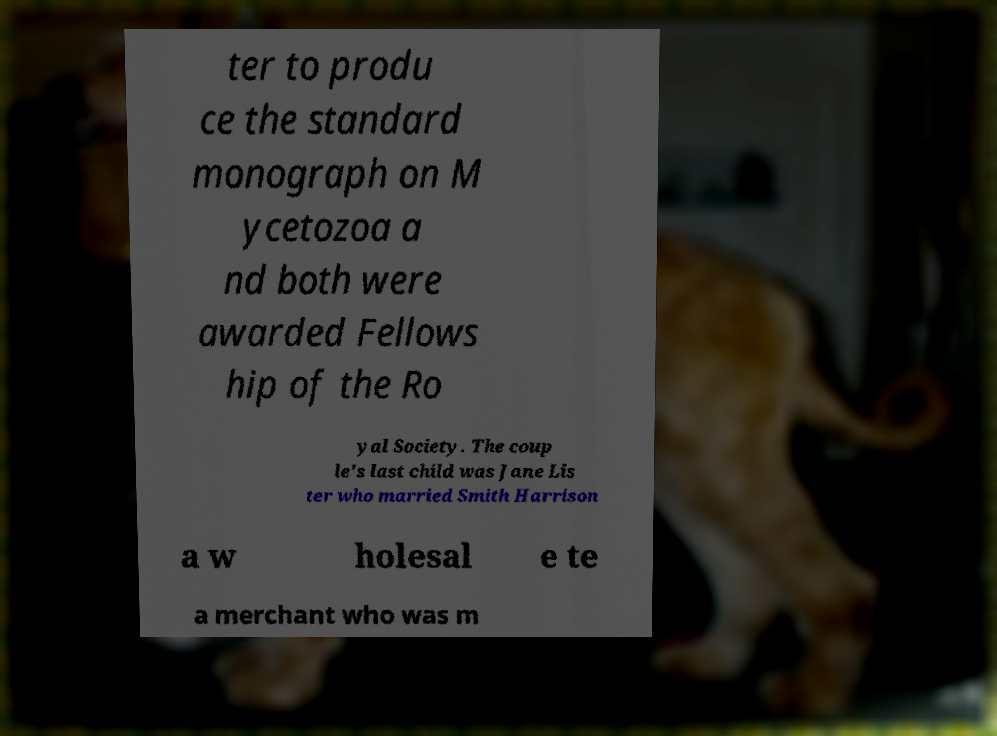I need the written content from this picture converted into text. Can you do that? ter to produ ce the standard monograph on M ycetozoa a nd both were awarded Fellows hip of the Ro yal Society. The coup le's last child was Jane Lis ter who married Smith Harrison a w holesal e te a merchant who was m 